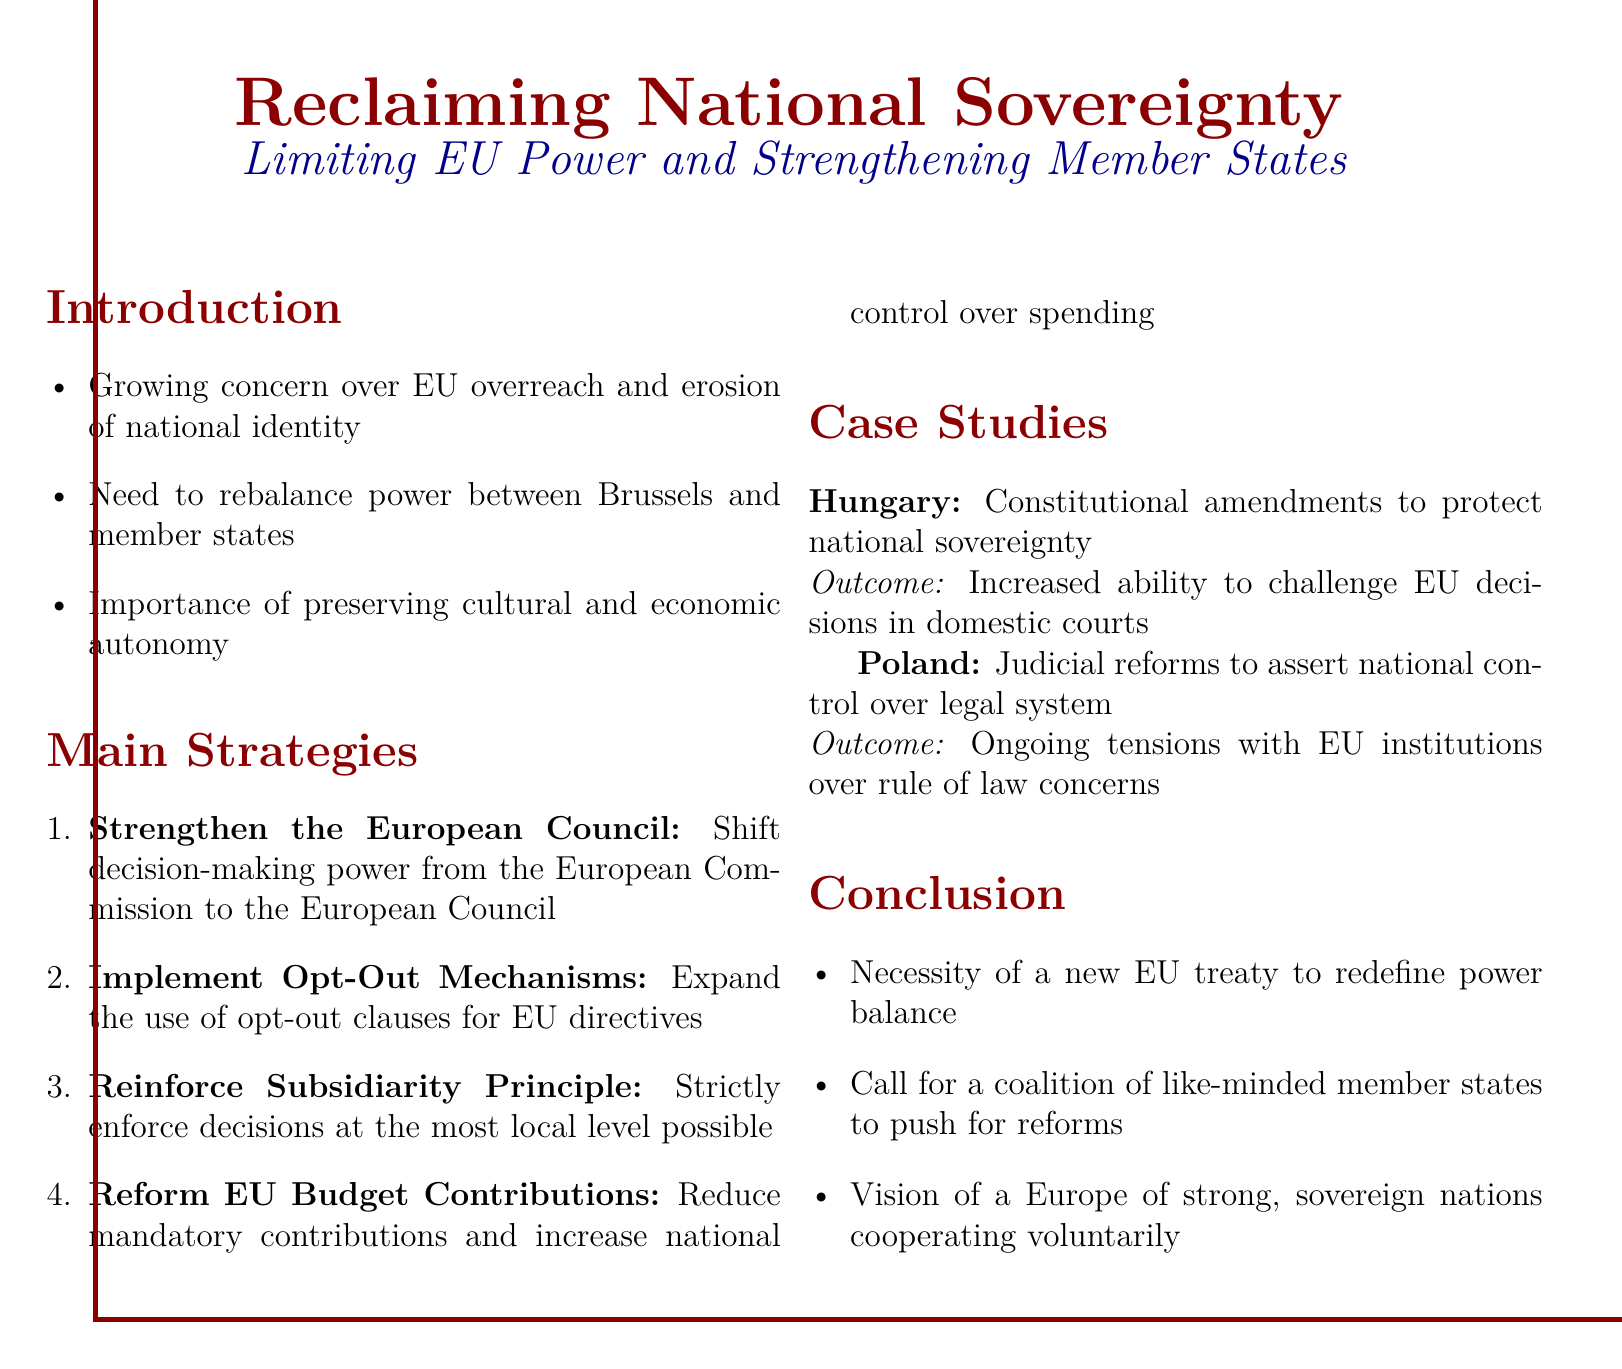What is the title of the document? The title of the document is prominently presented at the top.
Answer: Reclaiming National Sovereignty What are the main strategies proposed? The document lists four main strategies aimed at strengthening national sovereignty.
Answer: Strengthen the European Council, Implement Opt-Out Mechanisms, Reinforce Subsidiarity Principle, Reform EU Budget Contributions What country is mentioned in the case studies? The document includes case studies about specific countries.
Answer: Hungary and Poland What outcome did Hungary achieve? The document states the outcome of Hungary's approach to EU decisions.
Answer: Increased ability to challenge EU decisions in domestic courts What is the proposed necessity noted in the conclusion? The conclusion emphasizes the need for a significant change in the EU structure.
Answer: A new EU treaty What is the vision for Europe mentioned in the conclusion? The vision outlined in the conclusion reflects a certain perspective on European cooperation.
Answer: A Europe of strong, sovereign nations cooperating voluntarily Which principle should be enforced strictly according to the strategies? The document emphasizes a key principle in governing decision-making.
Answer: Subsidiarity Principle What does the document call for among member states? The conclusion articulates a call to action for specific collaboration.
Answer: A coalition of like-minded member states 